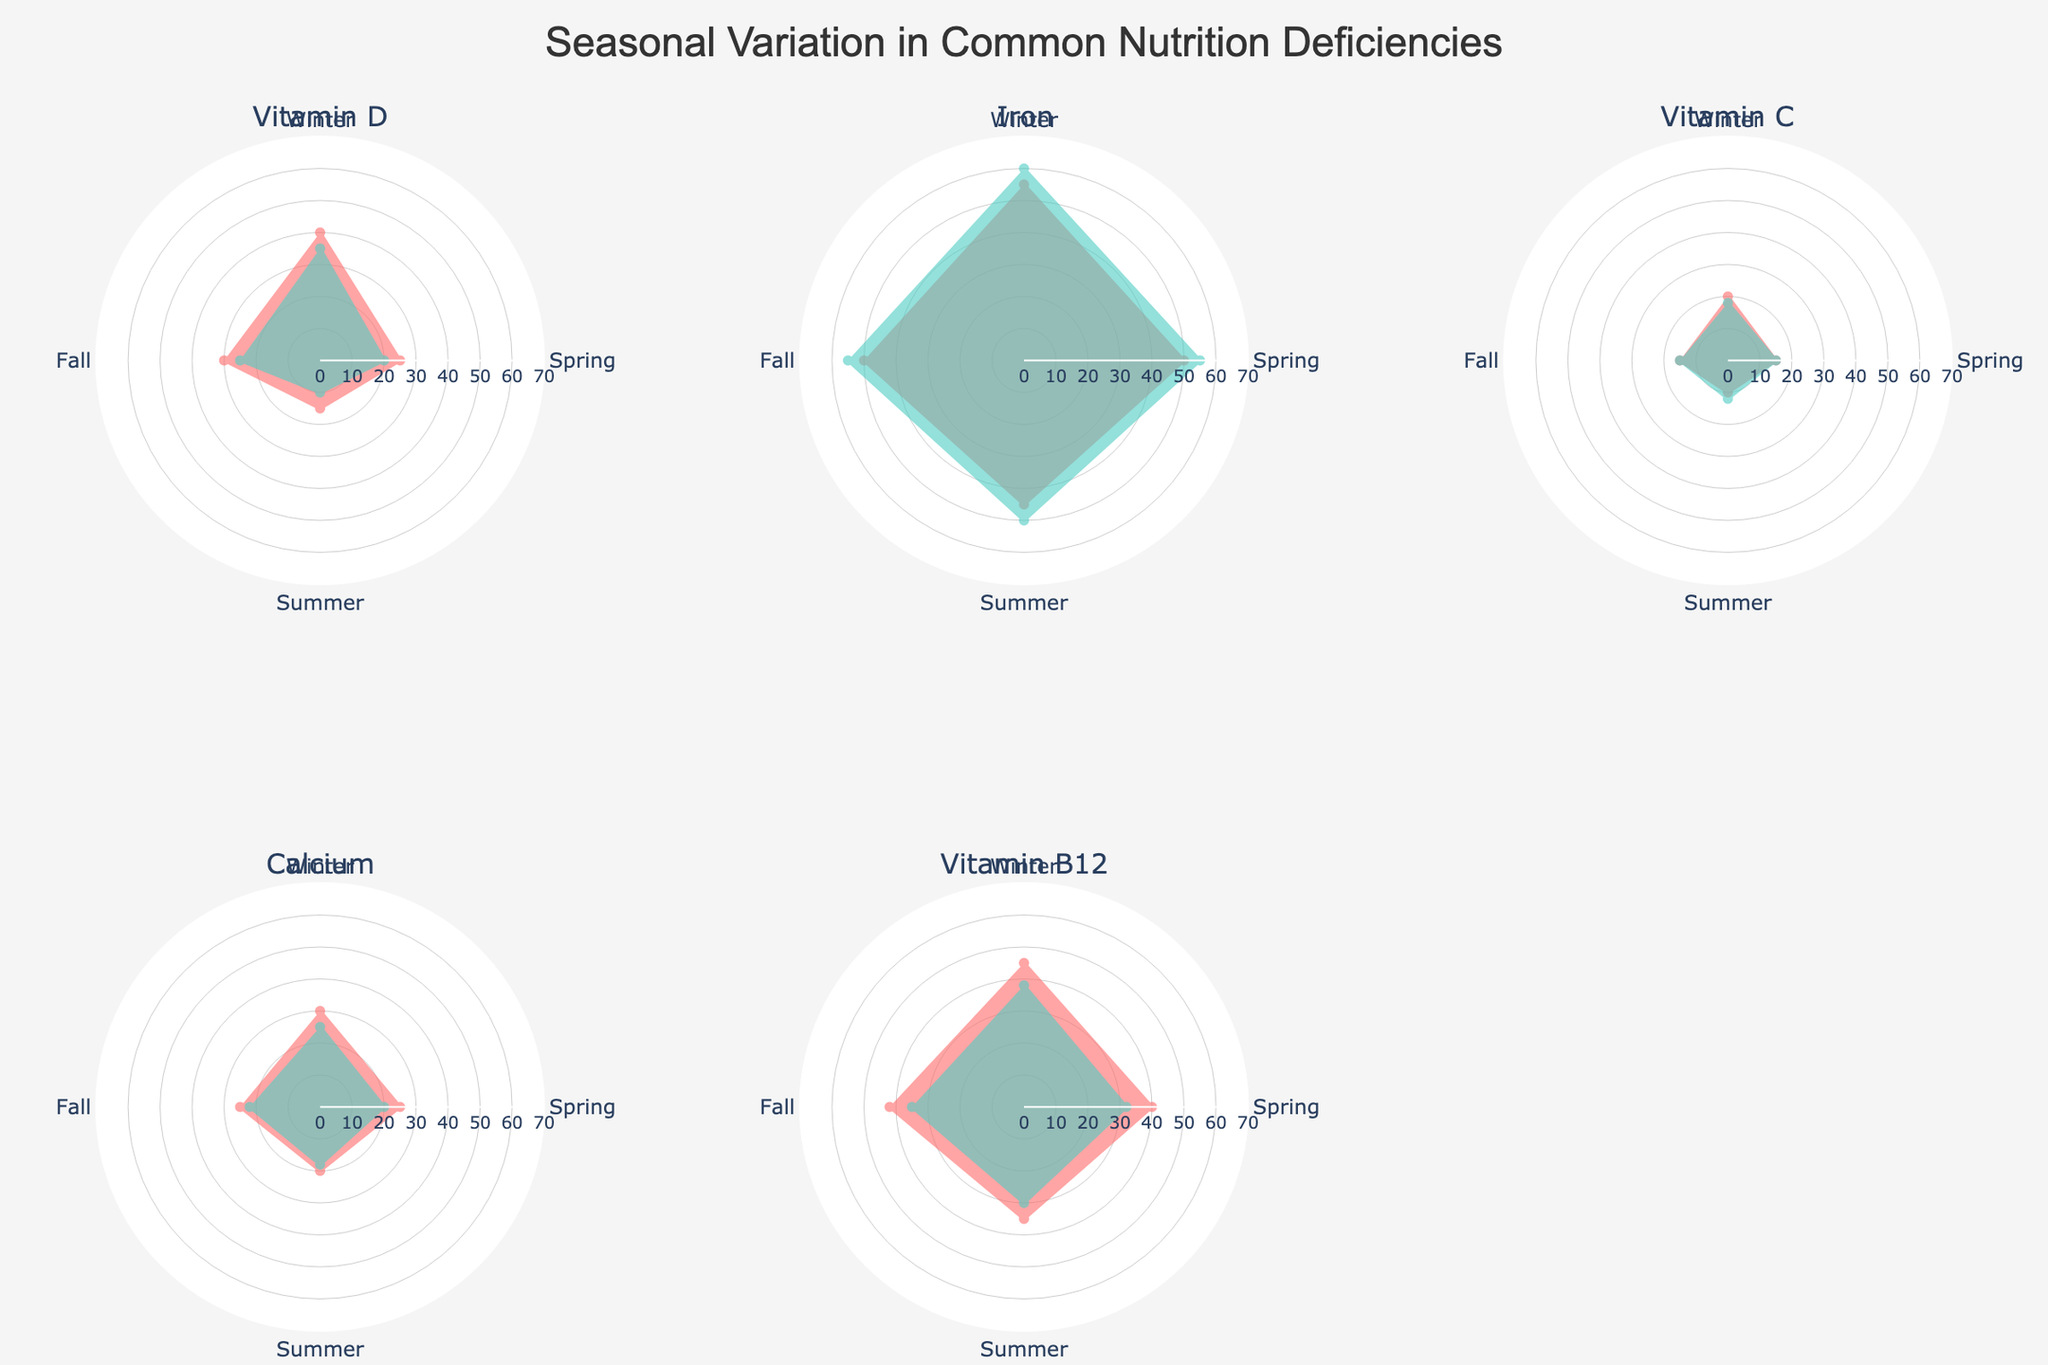What is the title of the figure? The title is usually found at the top center of the figure, which describes the overall content. In this case, it reads "Seasonal Variation in Common Nutrition Deficiencies."
Answer: Seasonal Variation in Common Nutrition Deficiencies Which group has the highest Vitamin D deficiency in the Winter? Look for the subplot associated with Vitamin D and identify the group with the largest segment in the Winter. Children have a 40 value.
Answer: Children During which season do pregnant women experience the least iron deficiency? In the Iron subplot, examine the values for Pregnant Women across all four seasons. The smallest value is during Summer with 50.
Answer: Summer Compare the Vitamin C deficiencies in Elderly and Teens during Fall. Which group is higher and by how much? For the Vitamin C subplot, compare the values in the Fall for both Elderly (15) and Teens (15). Both have the same value.
Answer: They are equal What is the difference in Calcium deficiency between Women over 50 and Men over 50 in Summer? In the Calcium subplot, find the Summer values for both Women over 50 (20) and Men over 50 (18). The difference is 20-18=2.
Answer: 2 Which deficiency shows the most significant seasonal variation in Adults? Look for the subplot of each deficiency that includes Adults and examine the variation. Vitamin D ranges from 35 in Winter to 10 in Summer, showing the largest difference.
Answer: Vitamin D How does Vitamin B12 deficiency in Vegan Adults change from Winter to Summer? Observe the trends in the Vitamin B12 subplot for Vegan Adults. The value decreases from Winter (45) to Summer (35).
Answer: Decreases What is the average Iron deficiency for Women across all seasons? Add up the Iron deficiency values for Women across Winter (55), Spring (50), Summer (45), and Fall (50), then divide by 4. The average is (55 + 50 + 45 + 50)/4 = 50.
Answer: 50 Which group has a higher Vitamin C deficiency in Spring, Elderly or Teens? Check the Vitamin C subplot for Spring values of Elderly (15) and Teens (15). They both have the same deficiency.
Answer: They are equal What is the highest deficiency value recorded in any season across all groups? Look through all the subplots and identify the highest value, which is in the Iron subplot for Pregnant Women during Winter (60).
Answer: 60 